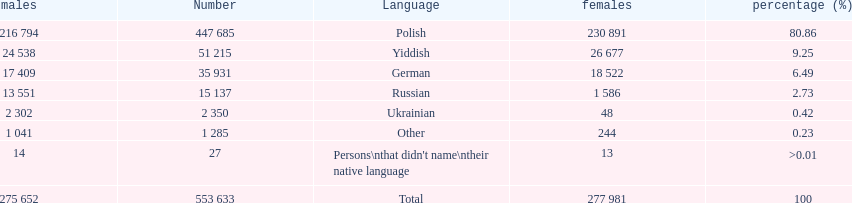How many languages have a name that is derived from a country? 4. 